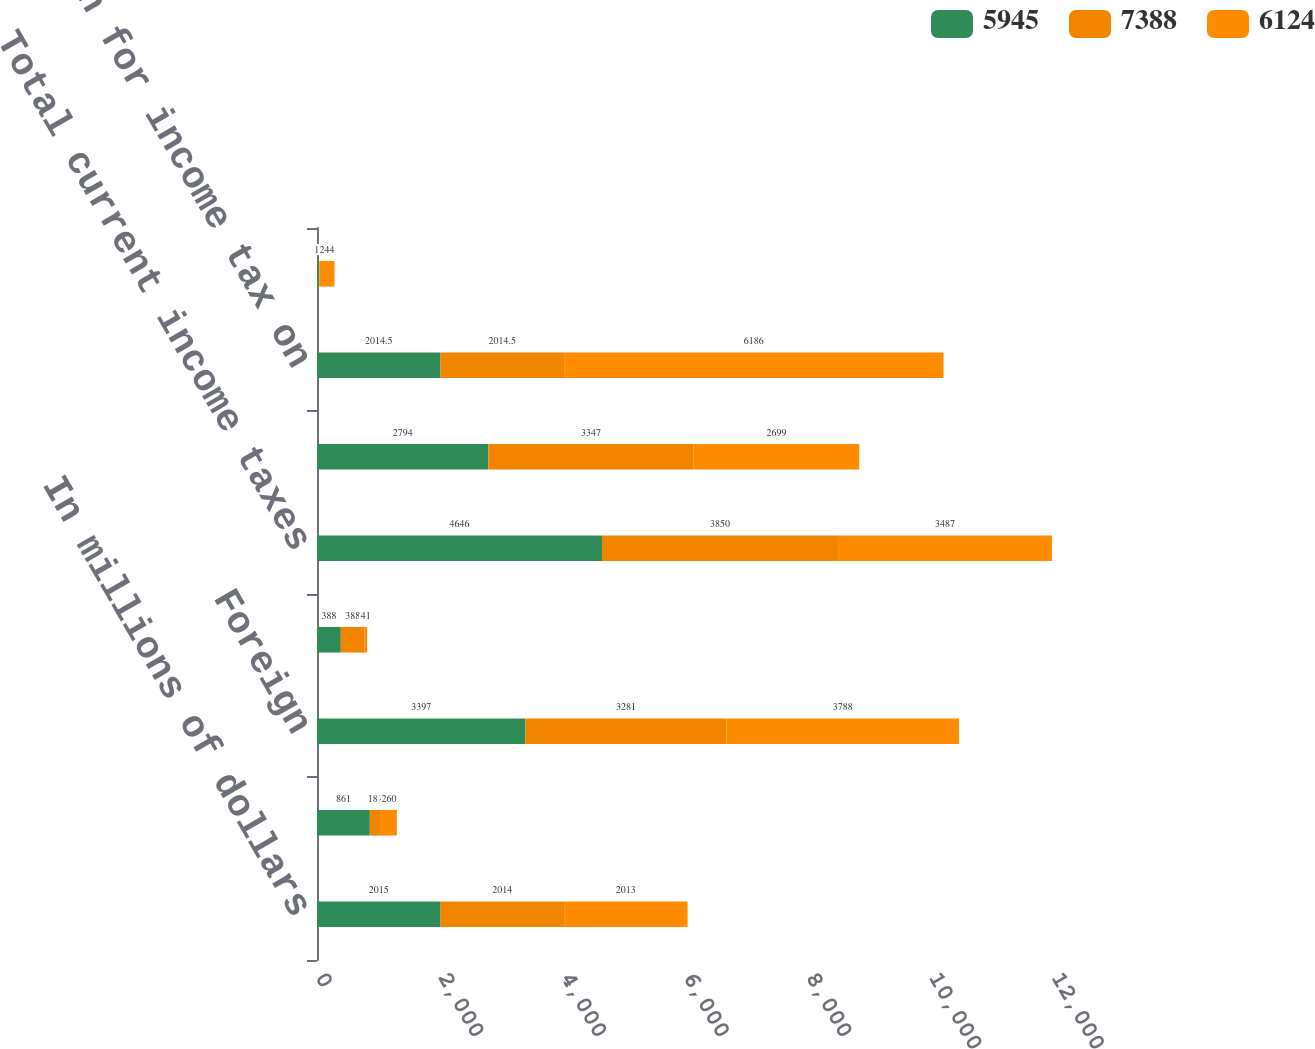<chart> <loc_0><loc_0><loc_500><loc_500><stacked_bar_chart><ecel><fcel>In millions of dollars<fcel>Federal<fcel>Foreign<fcel>State<fcel>Total current income taxes<fcel>Total deferred income taxes<fcel>Provision for income tax on<fcel>Provision (benefit) for income<nl><fcel>5945<fcel>2015<fcel>861<fcel>3397<fcel>388<fcel>4646<fcel>2794<fcel>2014.5<fcel>29<nl><fcel>7388<fcel>2014<fcel>181<fcel>3281<fcel>388<fcel>3850<fcel>3347<fcel>2014.5<fcel>12<nl><fcel>6124<fcel>2013<fcel>260<fcel>3788<fcel>41<fcel>3487<fcel>2699<fcel>6186<fcel>244<nl></chart> 